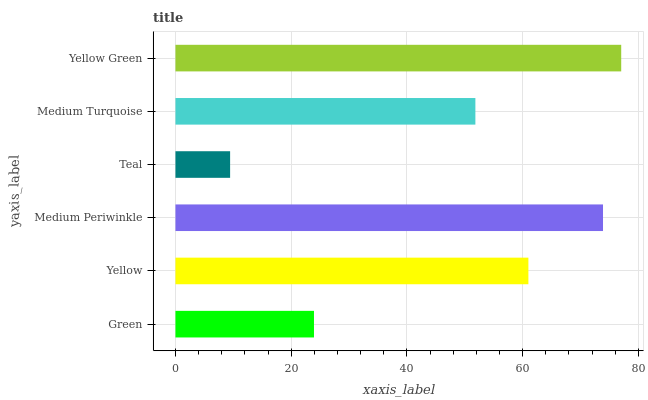Is Teal the minimum?
Answer yes or no. Yes. Is Yellow Green the maximum?
Answer yes or no. Yes. Is Yellow the minimum?
Answer yes or no. No. Is Yellow the maximum?
Answer yes or no. No. Is Yellow greater than Green?
Answer yes or no. Yes. Is Green less than Yellow?
Answer yes or no. Yes. Is Green greater than Yellow?
Answer yes or no. No. Is Yellow less than Green?
Answer yes or no. No. Is Yellow the high median?
Answer yes or no. Yes. Is Medium Turquoise the low median?
Answer yes or no. Yes. Is Green the high median?
Answer yes or no. No. Is Teal the low median?
Answer yes or no. No. 